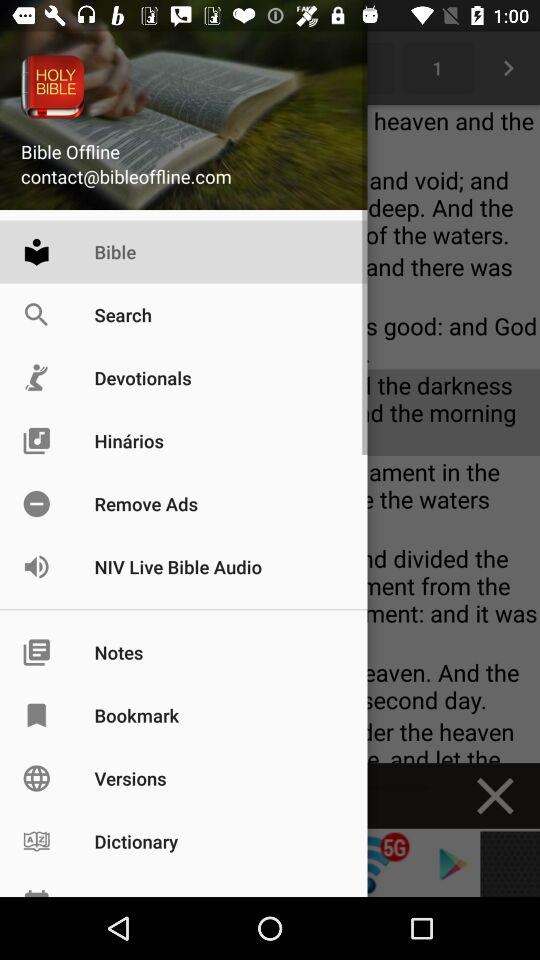Which item is selected in the menu? The selected item is "Bible". 